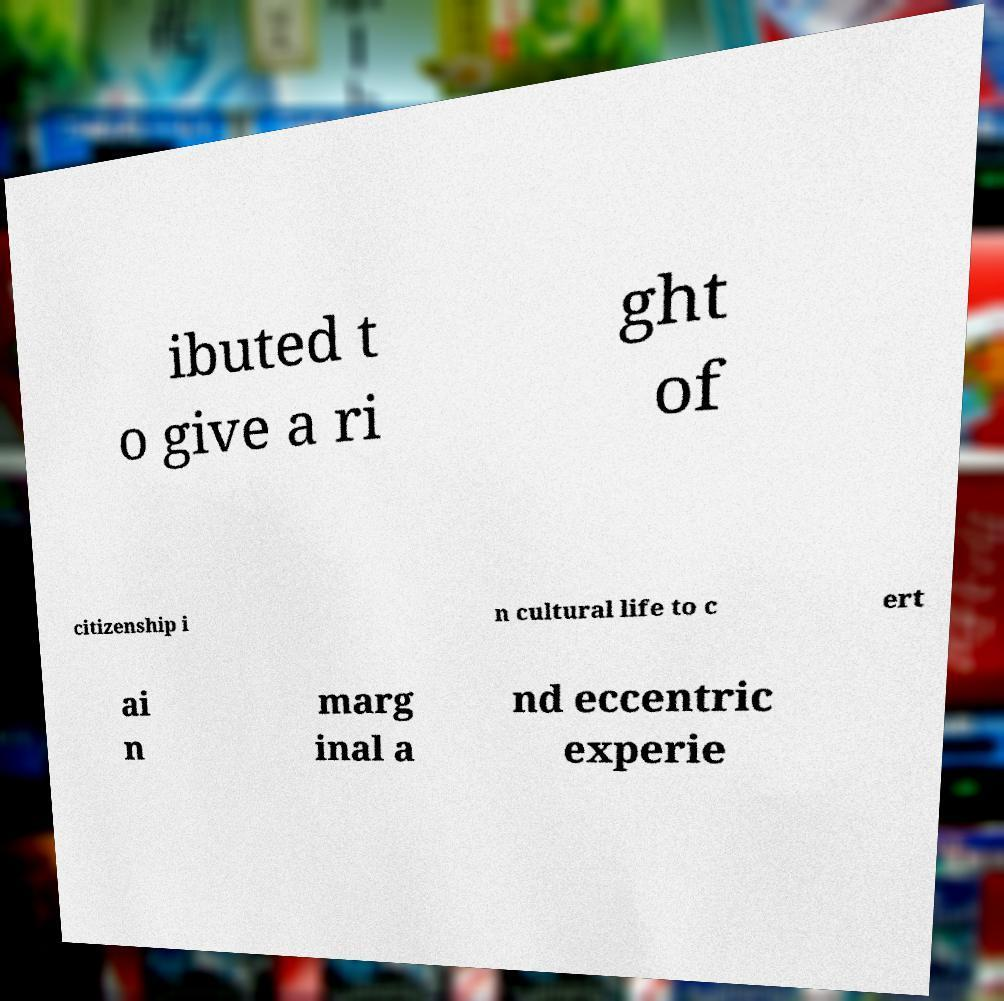Can you read and provide the text displayed in the image?This photo seems to have some interesting text. Can you extract and type it out for me? ibuted t o give a ri ght of citizenship i n cultural life to c ert ai n marg inal a nd eccentric experie 